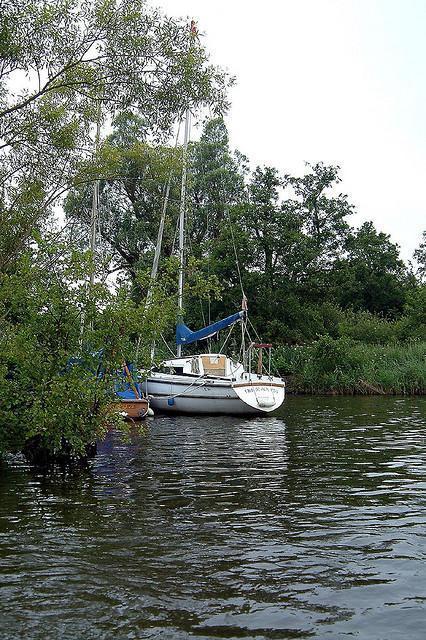How many people are in the water?
Give a very brief answer. 0. 